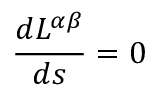<formula> <loc_0><loc_0><loc_500><loc_500>\frac { d L ^ { \alpha \beta } } { d s } = 0</formula> 